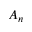<formula> <loc_0><loc_0><loc_500><loc_500>A _ { n }</formula> 